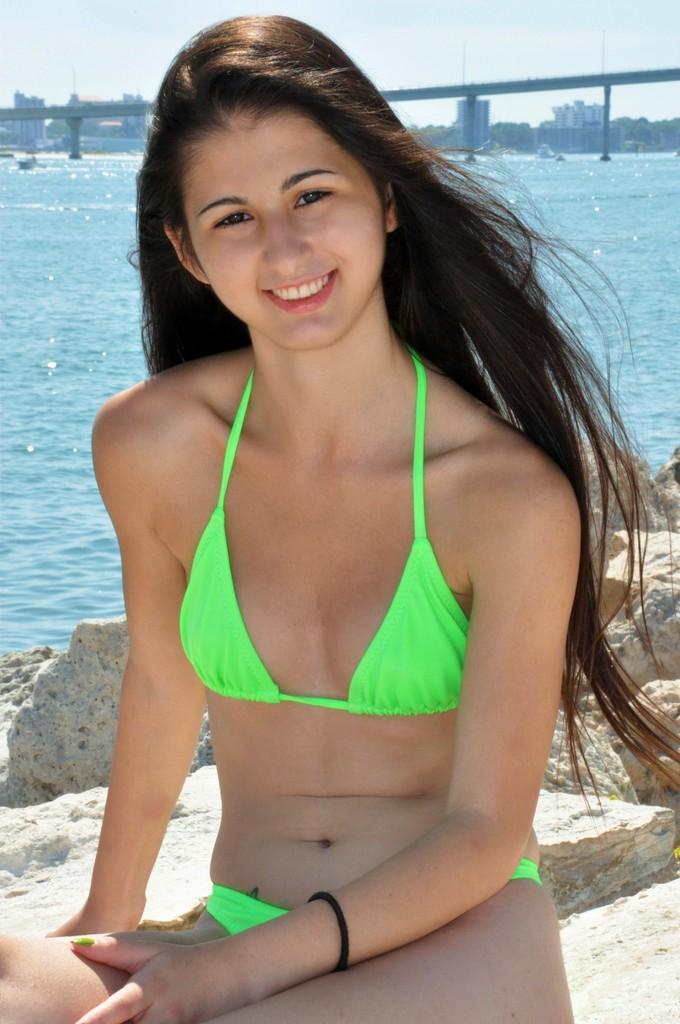How would you summarize this image in a sentence or two? Here we can see a woman and she is smiling. In the background we can see water, rocks, bridge, buildings, and sky. 